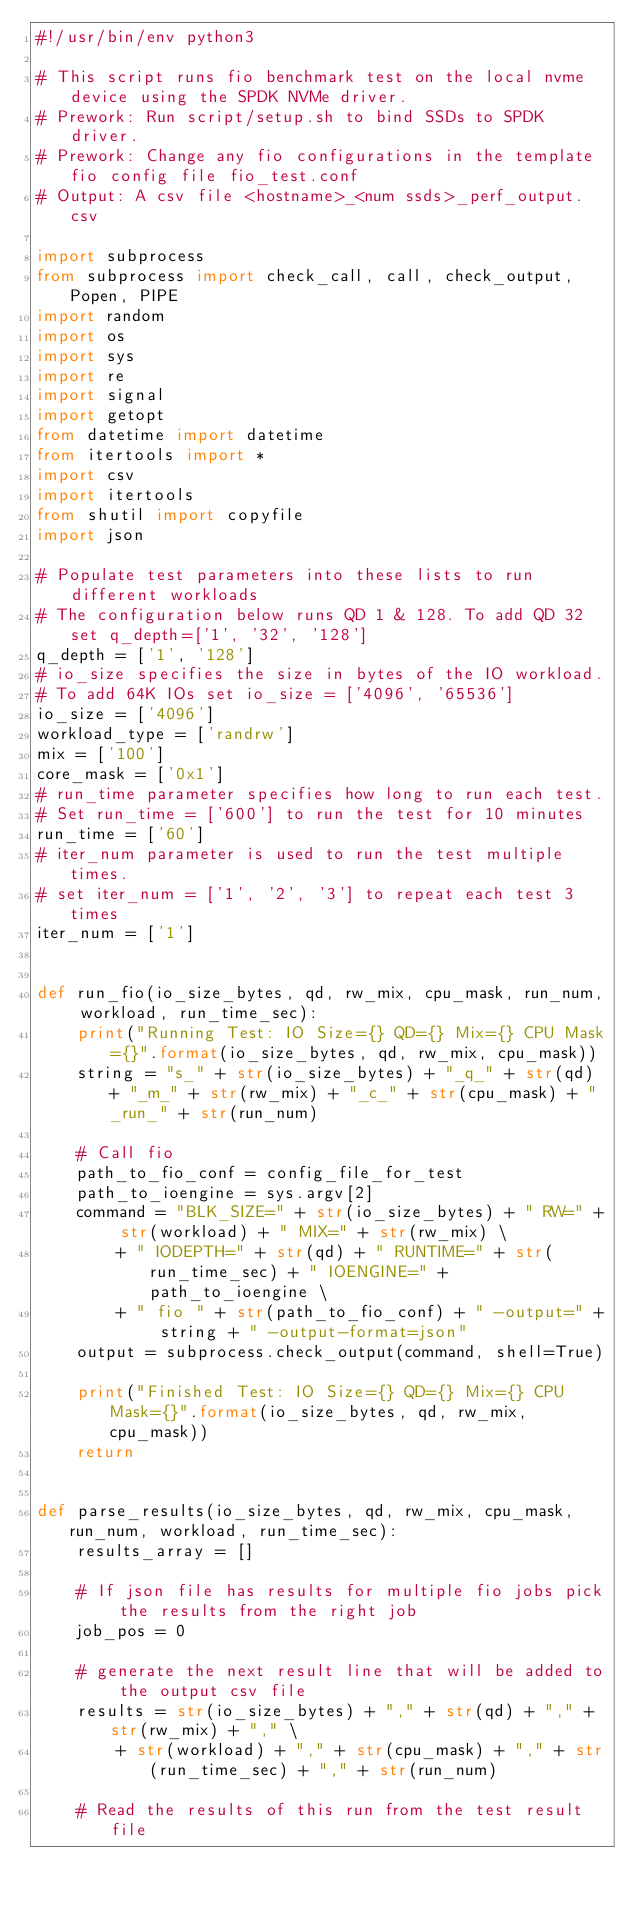Convert code to text. <code><loc_0><loc_0><loc_500><loc_500><_Python_>#!/usr/bin/env python3

# This script runs fio benchmark test on the local nvme device using the SPDK NVMe driver.
# Prework: Run script/setup.sh to bind SSDs to SPDK driver.
# Prework: Change any fio configurations in the template fio config file fio_test.conf
# Output: A csv file <hostname>_<num ssds>_perf_output.csv

import subprocess
from subprocess import check_call, call, check_output, Popen, PIPE
import random
import os
import sys
import re
import signal
import getopt
from datetime import datetime
from itertools import *
import csv
import itertools
from shutil import copyfile
import json

# Populate test parameters into these lists to run different workloads
# The configuration below runs QD 1 & 128. To add QD 32 set q_depth=['1', '32', '128']
q_depth = ['1', '128']
# io_size specifies the size in bytes of the IO workload.
# To add 64K IOs set io_size = ['4096', '65536']
io_size = ['4096']
workload_type = ['randrw']
mix = ['100']
core_mask = ['0x1']
# run_time parameter specifies how long to run each test.
# Set run_time = ['600'] to run the test for 10 minutes
run_time = ['60']
# iter_num parameter is used to run the test multiple times.
# set iter_num = ['1', '2', '3'] to repeat each test 3 times
iter_num = ['1']


def run_fio(io_size_bytes, qd, rw_mix, cpu_mask, run_num, workload, run_time_sec):
    print("Running Test: IO Size={} QD={} Mix={} CPU Mask={}".format(io_size_bytes, qd, rw_mix, cpu_mask))
    string = "s_" + str(io_size_bytes) + "_q_" + str(qd) + "_m_" + str(rw_mix) + "_c_" + str(cpu_mask) + "_run_" + str(run_num)

    # Call fio
    path_to_fio_conf = config_file_for_test
    path_to_ioengine = sys.argv[2]
    command = "BLK_SIZE=" + str(io_size_bytes) + " RW=" + str(workload) + " MIX=" + str(rw_mix) \
        + " IODEPTH=" + str(qd) + " RUNTIME=" + str(run_time_sec) + " IOENGINE=" + path_to_ioengine \
        + " fio " + str(path_to_fio_conf) + " -output=" + string + " -output-format=json"
    output = subprocess.check_output(command, shell=True)

    print("Finished Test: IO Size={} QD={} Mix={} CPU Mask={}".format(io_size_bytes, qd, rw_mix, cpu_mask))
    return


def parse_results(io_size_bytes, qd, rw_mix, cpu_mask, run_num, workload, run_time_sec):
    results_array = []

    # If json file has results for multiple fio jobs pick the results from the right job
    job_pos = 0

    # generate the next result line that will be added to the output csv file
    results = str(io_size_bytes) + "," + str(qd) + "," + str(rw_mix) + "," \
        + str(workload) + "," + str(cpu_mask) + "," + str(run_time_sec) + "," + str(run_num)

    # Read the results of this run from the test result file</code> 